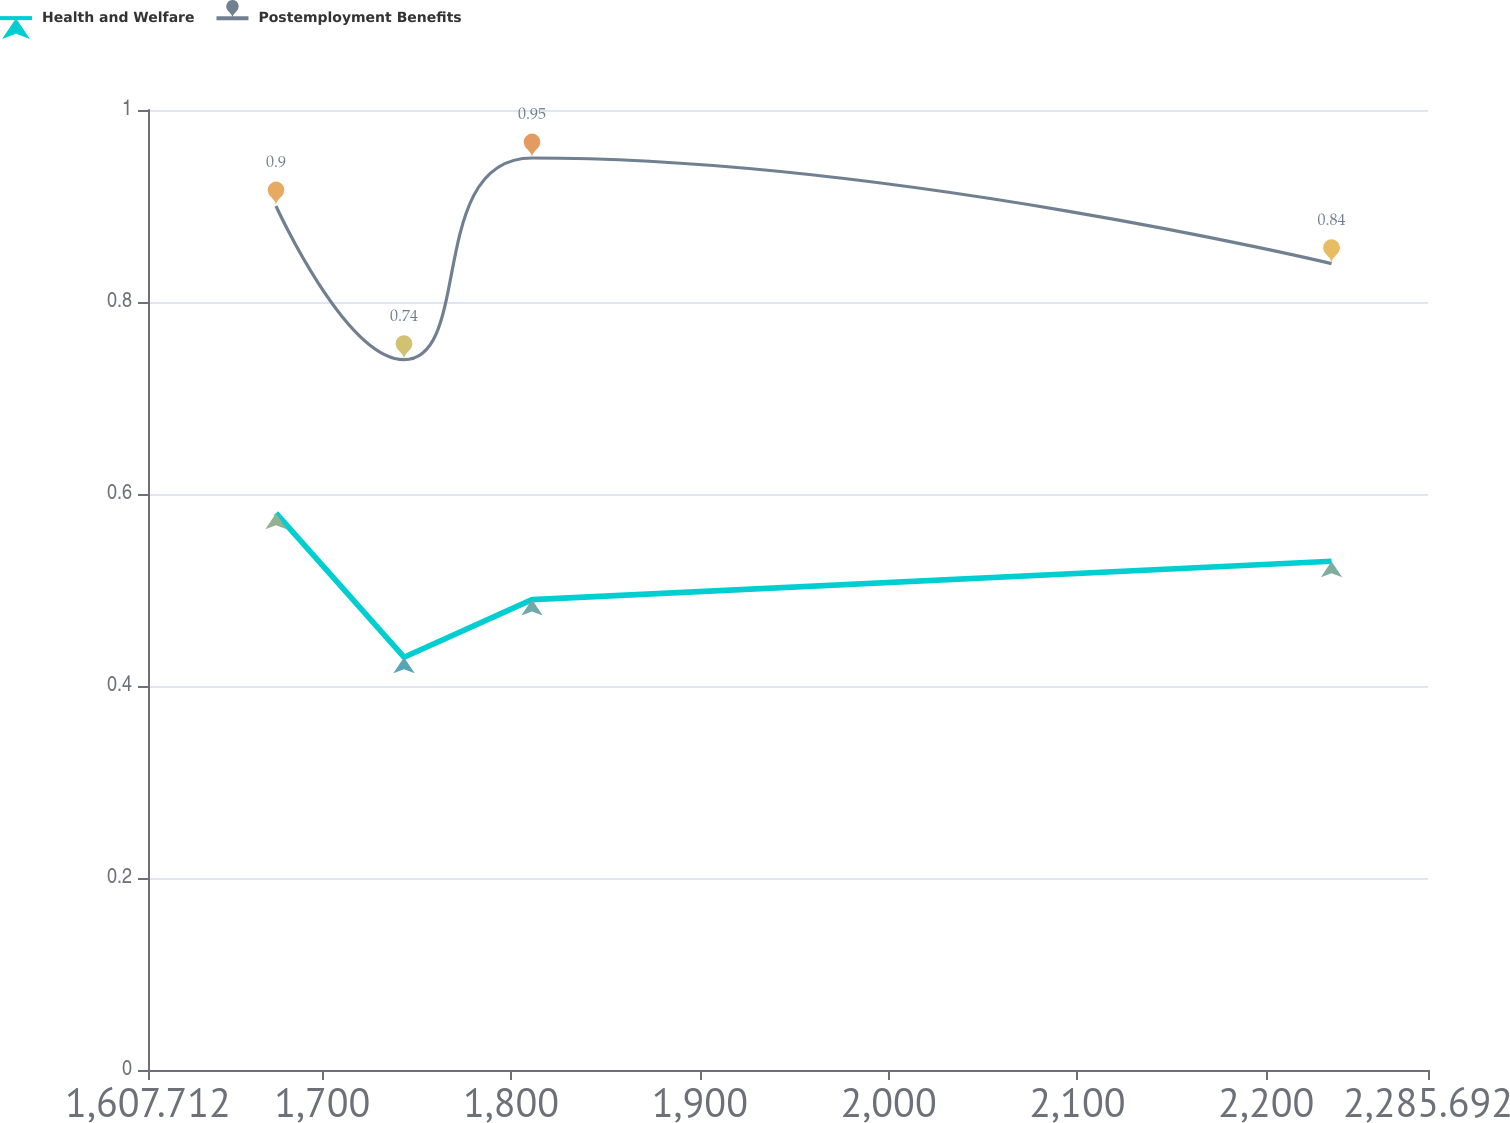Convert chart to OTSL. <chart><loc_0><loc_0><loc_500><loc_500><line_chart><ecel><fcel>Health and Welfare<fcel>Postemployment Benefits<nl><fcel>1675.51<fcel>0.58<fcel>0.9<nl><fcel>1743.31<fcel>0.43<fcel>0.74<nl><fcel>1811.11<fcel>0.49<fcel>0.95<nl><fcel>2234.59<fcel>0.53<fcel>0.84<nl><fcel>2353.49<fcel>0.41<fcel>1.2<nl></chart> 